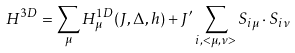<formula> <loc_0><loc_0><loc_500><loc_500>H ^ { 3 D } = \sum _ { \mu } H ^ { 1 D } _ { \mu } ( J , \Delta , h ) + J ^ { \prime } \sum _ { i , < \mu , \nu > } { S } _ { i \mu } \cdot { S } _ { i \nu }</formula> 